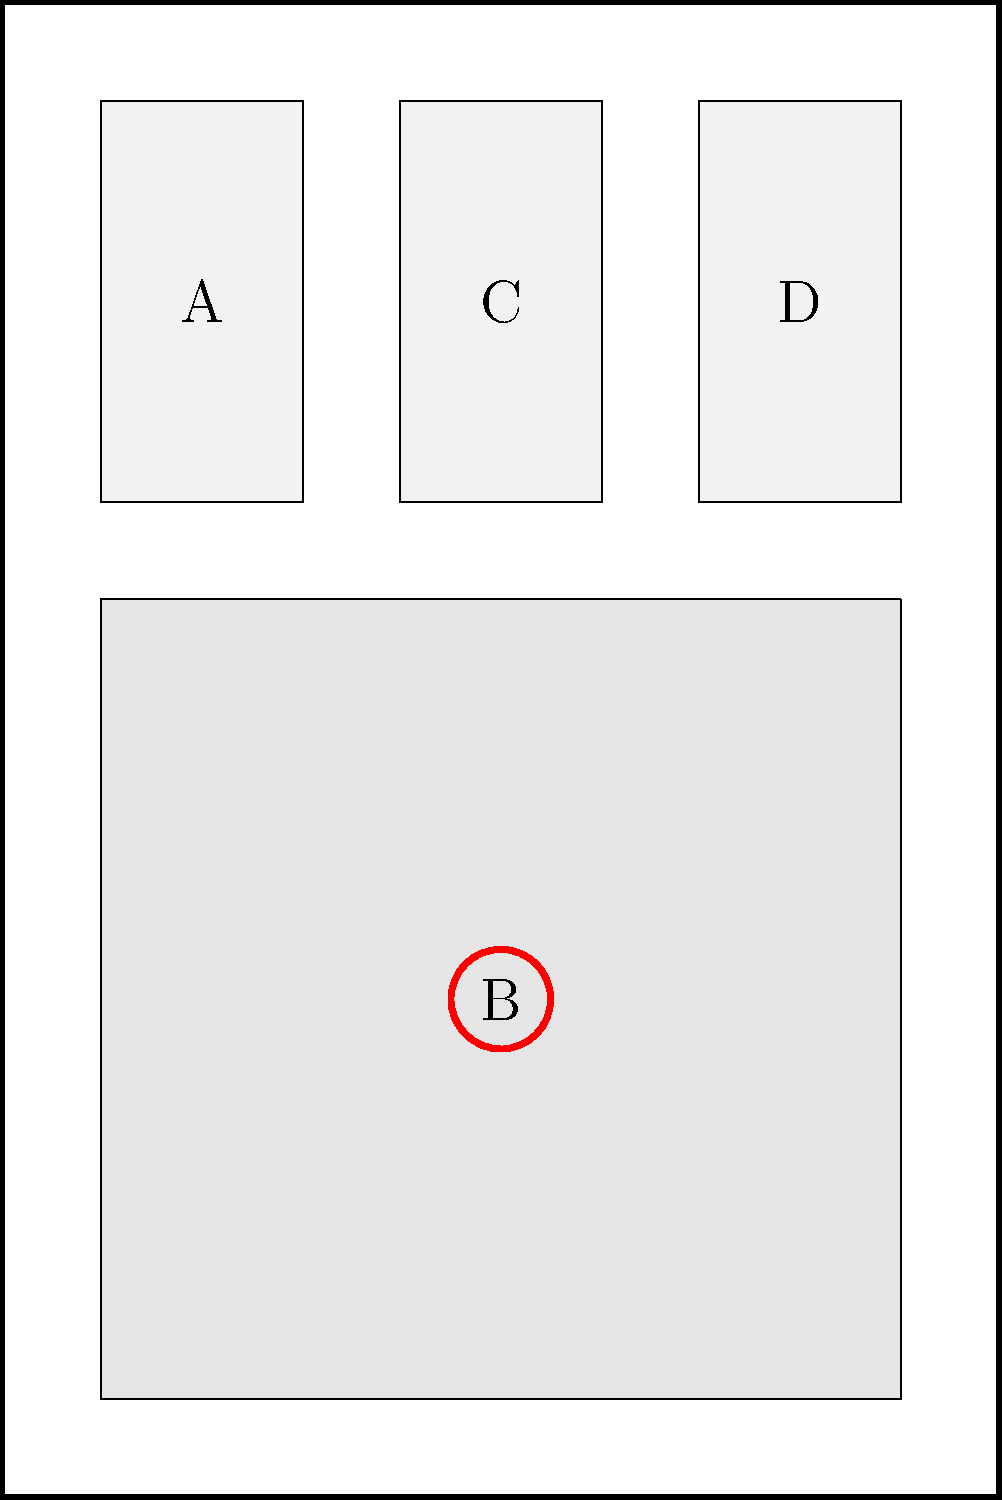In this complex comic book page layout, which panel is most likely to contain the focal point of the page, based on its size and position? To determine the focal point in a complex comic book page layout, we need to consider several factors:

1. Size: Larger panels tend to draw more attention and are often used for focal points.
2. Position: Central or prominent positions on the page are typically used for important elements.
3. Visual weight: Areas with more detail or contrast often become focal points.
4. Page flow: The natural reading direction (typically left to right, top to bottom in Western comics) influences where readers' eyes are drawn.

Analyzing the given layout:

1. Panel A (bottom left): Small size, less prominent position.
2. Panel B (large central): Largest size, central position, marked with a red circle.
3. Panel C (bottom center): Small size, somewhat central but not prominent.
4. Panel D (top right): Small size, less prominent position.

Panel B stands out as the most likely focal point due to its:
- Significantly larger size compared to other panels
- Central position on the page
- Visual emphasis (indicated by the red circle)

This panel would naturally draw the reader's eye and likely contain the most important or impactful content on the page.
Answer: Panel B 